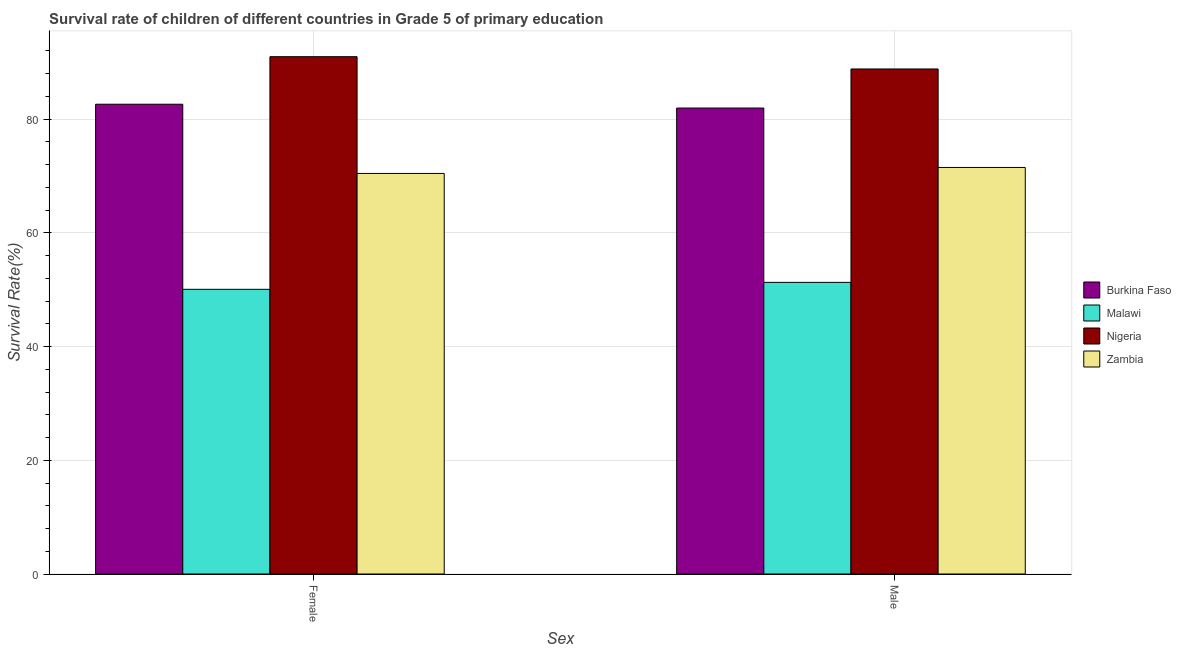How many groups of bars are there?
Ensure brevity in your answer.  2. Are the number of bars per tick equal to the number of legend labels?
Make the answer very short. Yes. What is the label of the 1st group of bars from the left?
Give a very brief answer. Female. What is the survival rate of female students in primary education in Burkina Faso?
Your response must be concise. 82.62. Across all countries, what is the maximum survival rate of female students in primary education?
Keep it short and to the point. 90.98. Across all countries, what is the minimum survival rate of female students in primary education?
Keep it short and to the point. 50.07. In which country was the survival rate of male students in primary education maximum?
Keep it short and to the point. Nigeria. In which country was the survival rate of male students in primary education minimum?
Your response must be concise. Malawi. What is the total survival rate of male students in primary education in the graph?
Offer a very short reply. 293.55. What is the difference between the survival rate of female students in primary education in Burkina Faso and that in Malawi?
Your answer should be compact. 32.55. What is the difference between the survival rate of female students in primary education in Malawi and the survival rate of male students in primary education in Zambia?
Offer a terse response. -21.43. What is the average survival rate of female students in primary education per country?
Offer a terse response. 73.53. What is the difference between the survival rate of male students in primary education and survival rate of female students in primary education in Burkina Faso?
Your answer should be very brief. -0.67. In how many countries, is the survival rate of male students in primary education greater than 16 %?
Offer a terse response. 4. What is the ratio of the survival rate of male students in primary education in Malawi to that in Zambia?
Provide a short and direct response. 0.72. What does the 2nd bar from the left in Female represents?
Your answer should be very brief. Malawi. What does the 1st bar from the right in Female represents?
Give a very brief answer. Zambia. How many bars are there?
Your response must be concise. 8. Are all the bars in the graph horizontal?
Your answer should be very brief. No. What is the title of the graph?
Offer a very short reply. Survival rate of children of different countries in Grade 5 of primary education. Does "Marshall Islands" appear as one of the legend labels in the graph?
Provide a succinct answer. No. What is the label or title of the X-axis?
Offer a terse response. Sex. What is the label or title of the Y-axis?
Ensure brevity in your answer.  Survival Rate(%). What is the Survival Rate(%) in Burkina Faso in Female?
Ensure brevity in your answer.  82.62. What is the Survival Rate(%) of Malawi in Female?
Give a very brief answer. 50.07. What is the Survival Rate(%) of Nigeria in Female?
Keep it short and to the point. 90.98. What is the Survival Rate(%) of Zambia in Female?
Offer a terse response. 70.44. What is the Survival Rate(%) in Burkina Faso in Male?
Offer a very short reply. 81.95. What is the Survival Rate(%) in Malawi in Male?
Your response must be concise. 51.29. What is the Survival Rate(%) in Nigeria in Male?
Give a very brief answer. 88.82. What is the Survival Rate(%) of Zambia in Male?
Your answer should be compact. 71.5. Across all Sex, what is the maximum Survival Rate(%) in Burkina Faso?
Make the answer very short. 82.62. Across all Sex, what is the maximum Survival Rate(%) of Malawi?
Offer a terse response. 51.29. Across all Sex, what is the maximum Survival Rate(%) in Nigeria?
Ensure brevity in your answer.  90.98. Across all Sex, what is the maximum Survival Rate(%) of Zambia?
Make the answer very short. 71.5. Across all Sex, what is the minimum Survival Rate(%) of Burkina Faso?
Give a very brief answer. 81.95. Across all Sex, what is the minimum Survival Rate(%) in Malawi?
Your answer should be compact. 50.07. Across all Sex, what is the minimum Survival Rate(%) of Nigeria?
Your response must be concise. 88.82. Across all Sex, what is the minimum Survival Rate(%) of Zambia?
Make the answer very short. 70.44. What is the total Survival Rate(%) in Burkina Faso in the graph?
Offer a terse response. 164.56. What is the total Survival Rate(%) in Malawi in the graph?
Provide a short and direct response. 101.36. What is the total Survival Rate(%) of Nigeria in the graph?
Offer a very short reply. 179.79. What is the total Survival Rate(%) in Zambia in the graph?
Keep it short and to the point. 141.94. What is the difference between the Survival Rate(%) in Burkina Faso in Female and that in Male?
Give a very brief answer. 0.67. What is the difference between the Survival Rate(%) in Malawi in Female and that in Male?
Offer a very short reply. -1.22. What is the difference between the Survival Rate(%) in Nigeria in Female and that in Male?
Keep it short and to the point. 2.16. What is the difference between the Survival Rate(%) in Zambia in Female and that in Male?
Your answer should be very brief. -1.05. What is the difference between the Survival Rate(%) in Burkina Faso in Female and the Survival Rate(%) in Malawi in Male?
Offer a terse response. 31.33. What is the difference between the Survival Rate(%) in Burkina Faso in Female and the Survival Rate(%) in Nigeria in Male?
Provide a succinct answer. -6.2. What is the difference between the Survival Rate(%) of Burkina Faso in Female and the Survival Rate(%) of Zambia in Male?
Your answer should be very brief. 11.12. What is the difference between the Survival Rate(%) of Malawi in Female and the Survival Rate(%) of Nigeria in Male?
Offer a very short reply. -38.75. What is the difference between the Survival Rate(%) in Malawi in Female and the Survival Rate(%) in Zambia in Male?
Ensure brevity in your answer.  -21.43. What is the difference between the Survival Rate(%) of Nigeria in Female and the Survival Rate(%) of Zambia in Male?
Make the answer very short. 19.48. What is the average Survival Rate(%) in Burkina Faso per Sex?
Provide a short and direct response. 82.28. What is the average Survival Rate(%) of Malawi per Sex?
Keep it short and to the point. 50.68. What is the average Survival Rate(%) of Nigeria per Sex?
Your answer should be compact. 89.9. What is the average Survival Rate(%) of Zambia per Sex?
Offer a terse response. 70.97. What is the difference between the Survival Rate(%) of Burkina Faso and Survival Rate(%) of Malawi in Female?
Your answer should be very brief. 32.55. What is the difference between the Survival Rate(%) in Burkina Faso and Survival Rate(%) in Nigeria in Female?
Provide a short and direct response. -8.36. What is the difference between the Survival Rate(%) of Burkina Faso and Survival Rate(%) of Zambia in Female?
Offer a terse response. 12.17. What is the difference between the Survival Rate(%) in Malawi and Survival Rate(%) in Nigeria in Female?
Your answer should be very brief. -40.91. What is the difference between the Survival Rate(%) in Malawi and Survival Rate(%) in Zambia in Female?
Offer a very short reply. -20.38. What is the difference between the Survival Rate(%) of Nigeria and Survival Rate(%) of Zambia in Female?
Your response must be concise. 20.53. What is the difference between the Survival Rate(%) in Burkina Faso and Survival Rate(%) in Malawi in Male?
Ensure brevity in your answer.  30.66. What is the difference between the Survival Rate(%) in Burkina Faso and Survival Rate(%) in Nigeria in Male?
Ensure brevity in your answer.  -6.87. What is the difference between the Survival Rate(%) of Burkina Faso and Survival Rate(%) of Zambia in Male?
Ensure brevity in your answer.  10.45. What is the difference between the Survival Rate(%) of Malawi and Survival Rate(%) of Nigeria in Male?
Provide a succinct answer. -37.53. What is the difference between the Survival Rate(%) in Malawi and Survival Rate(%) in Zambia in Male?
Your answer should be compact. -20.21. What is the difference between the Survival Rate(%) in Nigeria and Survival Rate(%) in Zambia in Male?
Provide a short and direct response. 17.32. What is the ratio of the Survival Rate(%) of Burkina Faso in Female to that in Male?
Provide a succinct answer. 1.01. What is the ratio of the Survival Rate(%) in Malawi in Female to that in Male?
Your answer should be compact. 0.98. What is the ratio of the Survival Rate(%) in Nigeria in Female to that in Male?
Provide a short and direct response. 1.02. What is the ratio of the Survival Rate(%) of Zambia in Female to that in Male?
Provide a succinct answer. 0.99. What is the difference between the highest and the second highest Survival Rate(%) in Burkina Faso?
Offer a terse response. 0.67. What is the difference between the highest and the second highest Survival Rate(%) of Malawi?
Your answer should be very brief. 1.22. What is the difference between the highest and the second highest Survival Rate(%) of Nigeria?
Offer a terse response. 2.16. What is the difference between the highest and the second highest Survival Rate(%) in Zambia?
Your response must be concise. 1.05. What is the difference between the highest and the lowest Survival Rate(%) of Burkina Faso?
Your answer should be compact. 0.67. What is the difference between the highest and the lowest Survival Rate(%) of Malawi?
Make the answer very short. 1.22. What is the difference between the highest and the lowest Survival Rate(%) in Nigeria?
Provide a short and direct response. 2.16. What is the difference between the highest and the lowest Survival Rate(%) of Zambia?
Offer a very short reply. 1.05. 